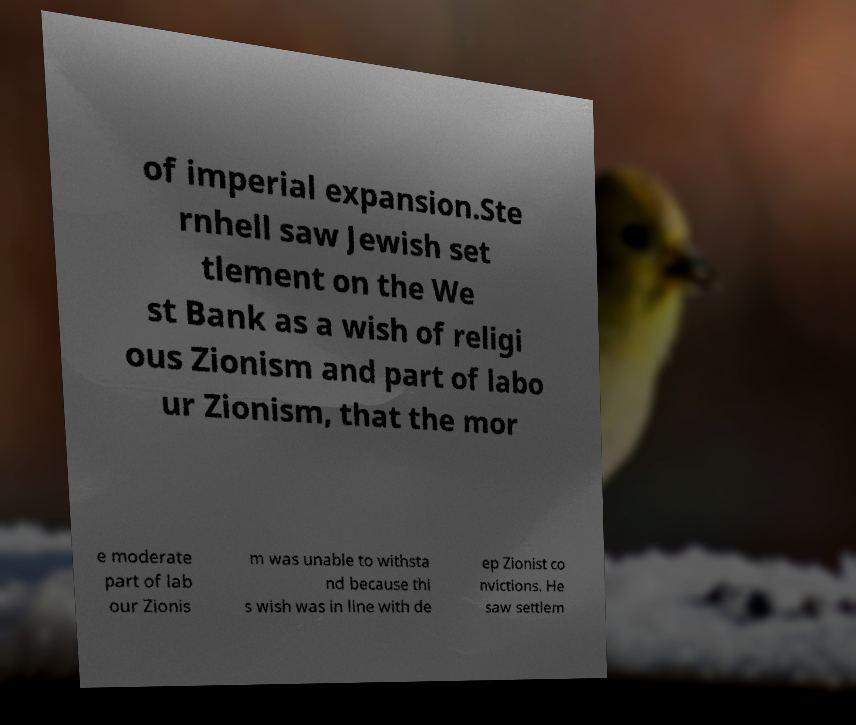Please read and relay the text visible in this image. What does it say? of imperial expansion.Ste rnhell saw Jewish set tlement on the We st Bank as a wish of religi ous Zionism and part of labo ur Zionism, that the mor e moderate part of lab our Zionis m was unable to withsta nd because thi s wish was in line with de ep Zionist co nvictions. He saw settlem 